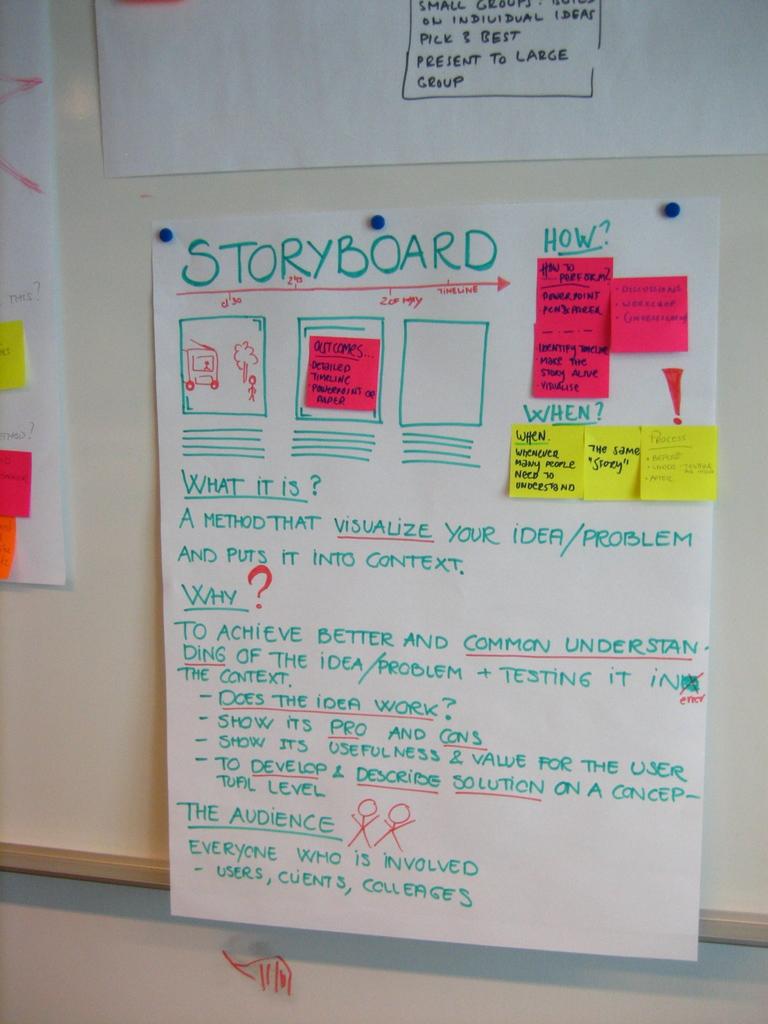What type of information is on this board?
Offer a terse response. Storyboard. What does is say about the audience at the bottom?
Keep it short and to the point. Everyone who is involved. 